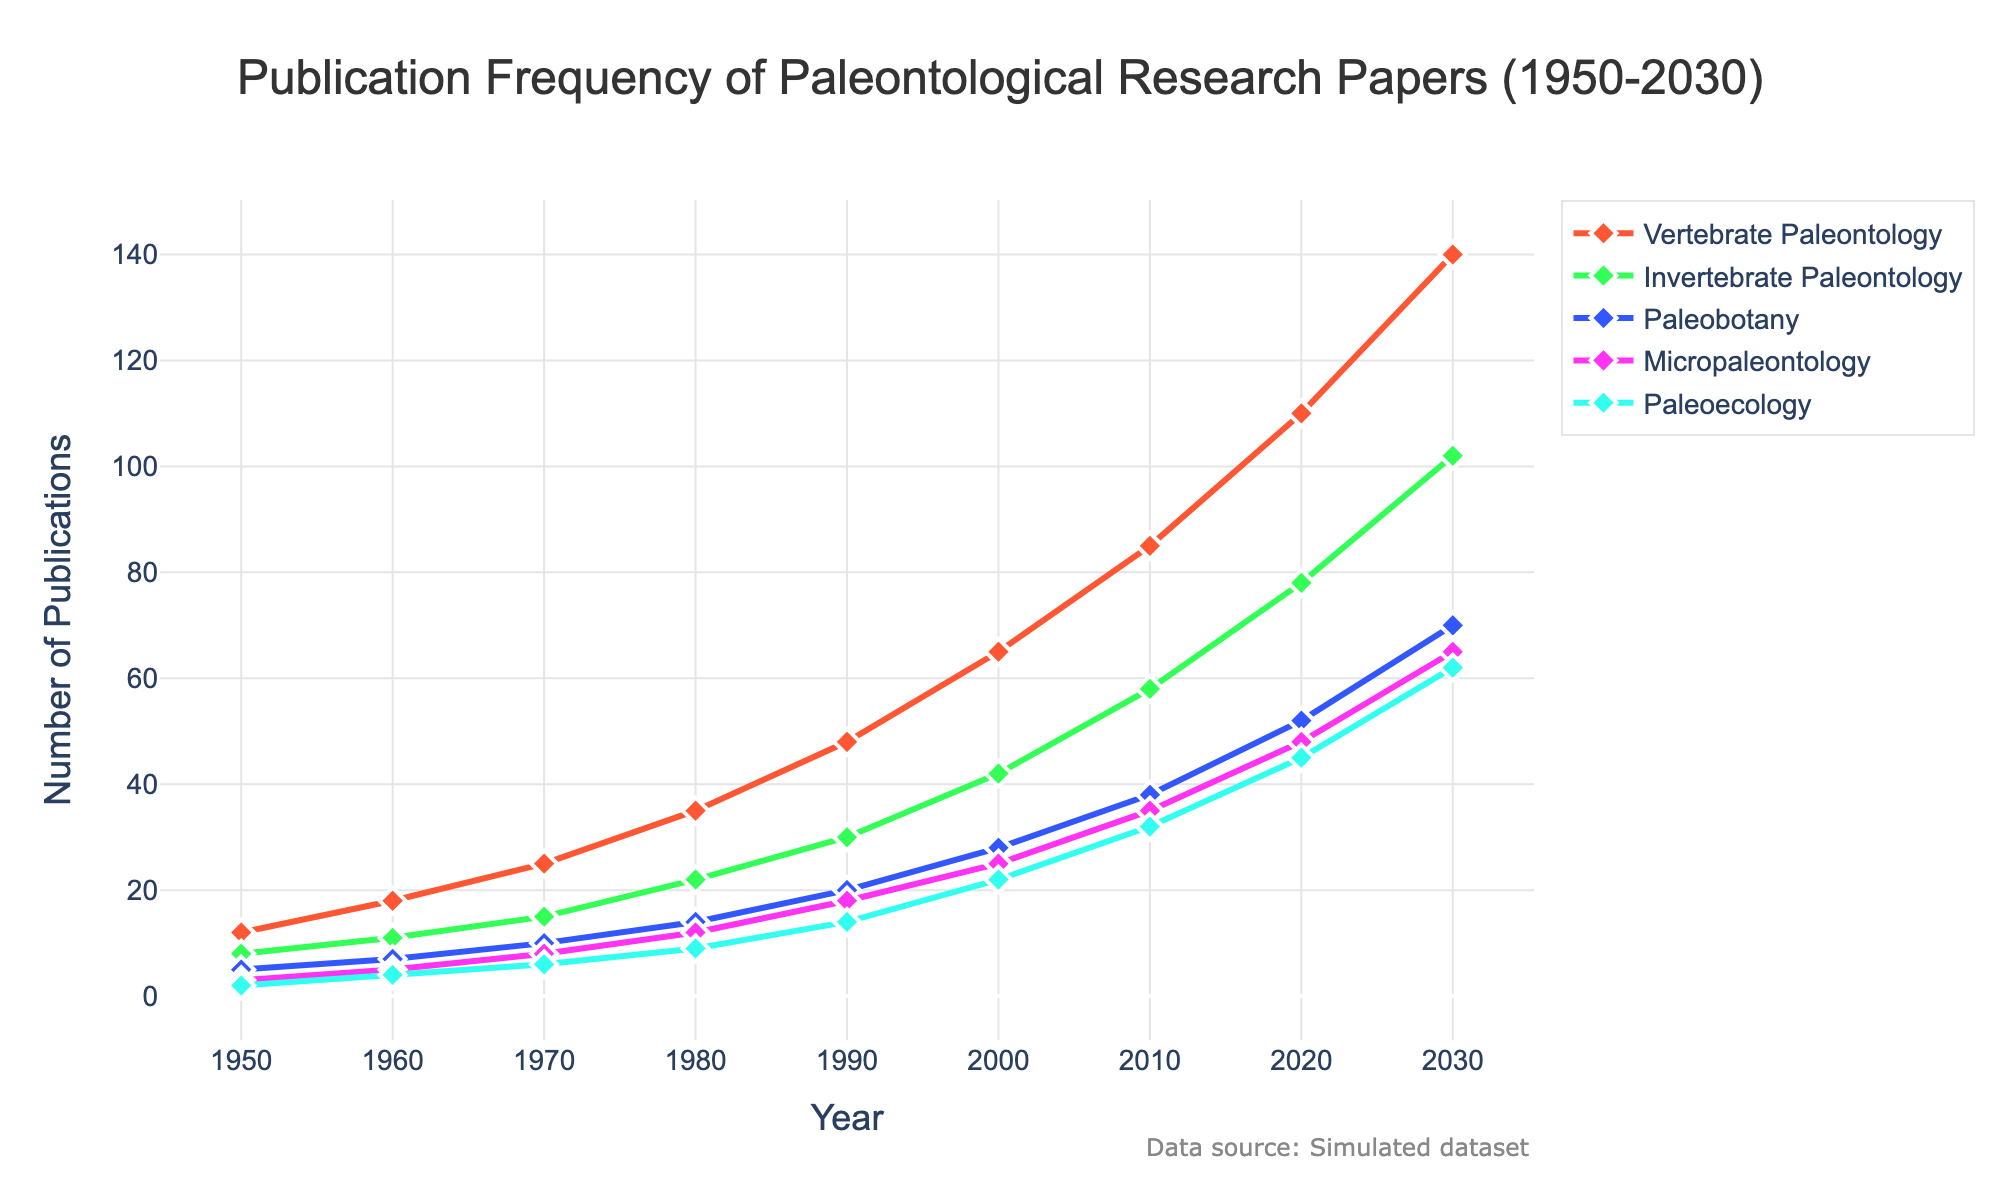What's the trend of publication frequency in Vertebrate Paleontology from 1950 to 2030? The trend shows that the publication frequency in Vertebrate Paleontology has been increasing continuously from 12 in 1950 to 140 in 2030. By carefully observing each data point along the line track for Vertebrate Paleontology in the chart, it's evident that there is a steady upward trajectory.
Answer: Steadily increasing Which subfield had the highest number of publications in 2020? To find which subfield had the highest number of publications in 2020, look at the data points in the chart for the year 2020 across all subfields. Vertebrate Paleontology has the highest value at 110.
Answer: Vertebrate Paleontology What is the difference in publication frequency between Micropaleontology and Paleoecology in 1970? In 1970, Micropaleontology had 8 publications and Paleoecology had 6. The difference is calculated by subtracting the number of publications in Paleoecology from those in Micropaleontology: 8 - 6 = 2.
Answer: 2 By how much did the number of publications in Invertebrate Paleontology increase from 1980 to 2000? Find the publication numbers for Invertebrate Paleontology for both years: 22 in 1980 and 42 in 2000. Subtract the 1980 value from the 2000 value: 42 - 22 = 20.
Answer: 20 Which subfield shows the highest growth in publications from 2010 to 2020? To find the subfield with the highest growth, calculate the difference in publications for each subfield between 2010 and 2020. The differences are: 
- Vertebrate Paleontology: 110 - 85 = 25
- Invertebrate Paleontology: 78 - 58 = 20
- Paleobotany: 52 - 38 = 14
- Micropaleontology: 48 - 35 = 13
- Paleoecology: 45 - 32 = 13
Vertebrate Paleontology shows the highest growth with 25 additional publications.
Answer: Vertebrate Paleontology What is the average number of publications in Paleoecology from 1950 to 2030? Add up the publication numbers for Paleoecology from each year and divide by the total number of years: (2 + 4 + 6 + 9 + 14 + 22 + 32 + 45 + 62) / 9 = 196 / 9 ≈ 21.78.
Answer: ~21.78 Which subfield had more publications in 1990: Paleobotany or Paleoecology? In 1990, Paleobotany had 20 publications, while Paleoecology had 14 publications. Therefore, Paleobotany had more publications.
Answer: Paleobotany What is the general color used to represent Invertebrate Paleontology in the chart? By examining the color-coded lines in the chart, Invertebrate Paleontology is represented in green.
Answer: Green How many total publications were there in the field of Paleobotany in 2030? According to the chart, there were 70 publications in Paleobotany in 2030.
Answer: 70 Which two subfields had the closest number of publications in 2000, and what was their difference? In 2000, the numbers are:
- Vertebrate Paleontology: 65
- Invertebrate Paleontology: 42
- Paleobotany: 28
- Micropaleontology: 25
- Paleoecology: 22
Micropaleontology and Paleoecology had the closest number of publications with a difference of 3.
Answer: Micropaleontology and Paleoecology, 3 